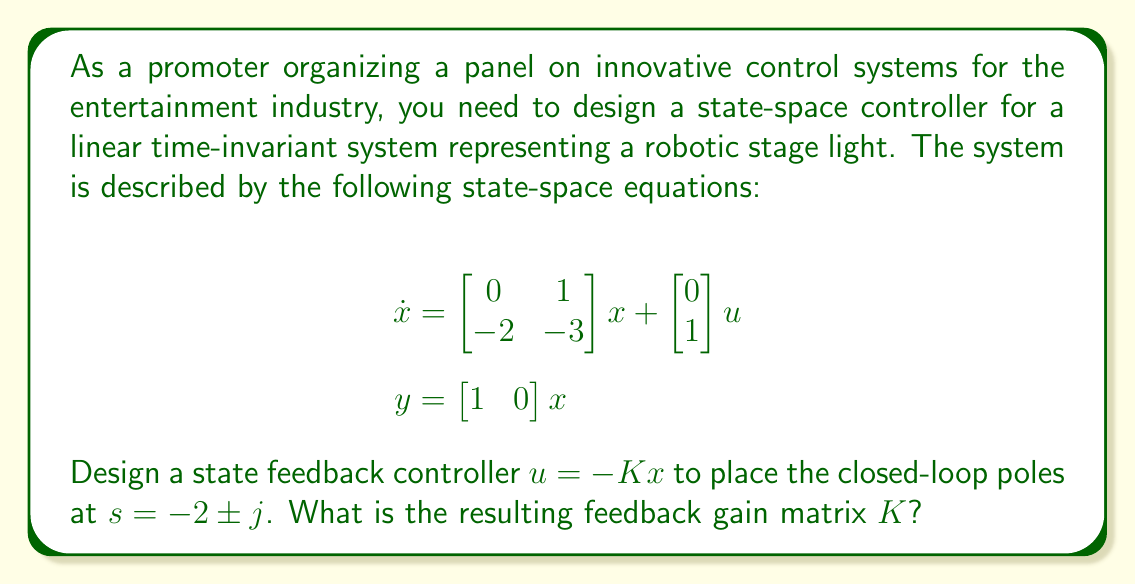Solve this math problem. To design the state feedback controller, we'll follow these steps:

1) First, we need to determine the characteristic equation of the closed-loop system. The closed-loop system matrix is given by $(A - BK)$, where:

   $A = \begin{bmatrix} 0 & 1 \\ -2 & -3 \end{bmatrix}$, $B = \begin{bmatrix} 0 \\ 1 \end{bmatrix}$, and $K = \begin{bmatrix} k_1 & k_2 \end{bmatrix}$

2) The characteristic equation is:

   $\det(sI - (A - BK)) = \det\begin{bmatrix} s & -1 \\ 2+k_1 & s+3+k_2 \end{bmatrix} = 0$

3) Expanding this determinant:

   $s^2 + (3+k_2)s + (2+k_1) = 0$

4) We want to place the poles at $s = -2 \pm j$. The characteristic equation for these desired poles is:

   $(s+2-j)(s+2+j) = s^2 + 4s + 5 = 0$

5) Comparing the coefficients of our actual and desired characteristic equations:

   $3+k_2 = 4$
   $2+k_1 = 5$

6) Solving these equations:

   $k_2 = 1$
   $k_1 = 3$

Therefore, the feedback gain matrix $K$ that places the closed-loop poles at $s = -2 \pm j$ is $\begin{bmatrix} 3 & 1 \end{bmatrix}$.
Answer: $K = \begin{bmatrix} 3 & 1 \end{bmatrix}$ 